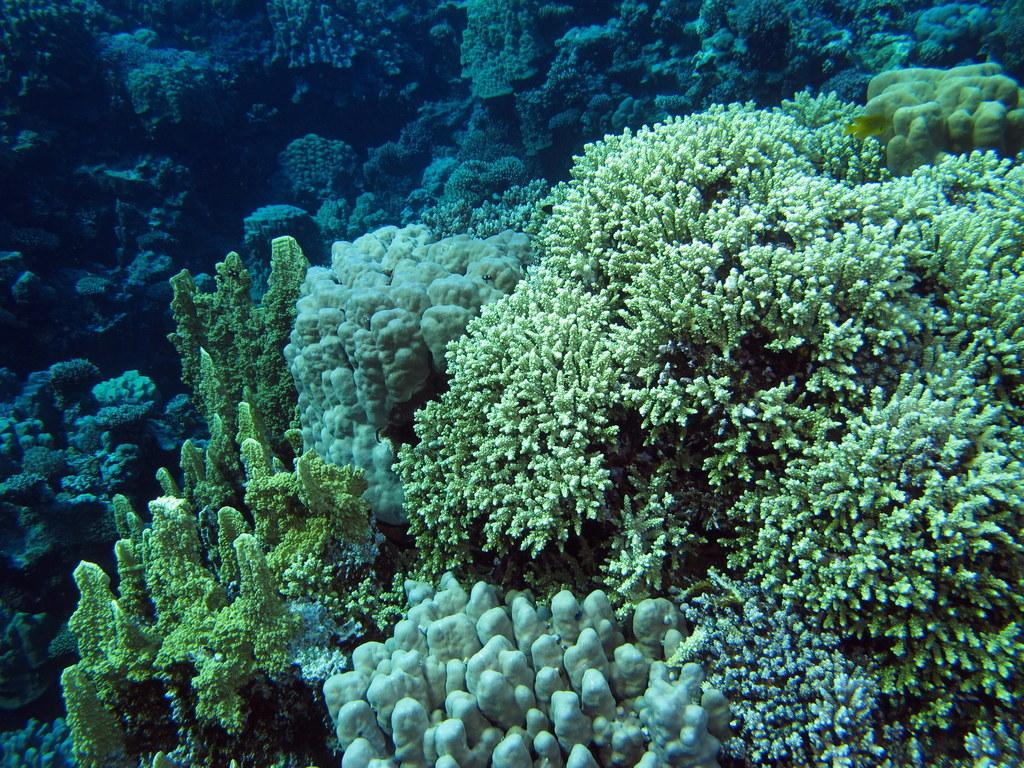What type of plants can be seen in the image? There are underwater plants in the image. How many yaks are swimming with the underwater plants in the image? There are no yaks present in the image; it features underwater plants only. What type of liquid surrounds the underwater plants in the image? The image does not specify the type of liquid surrounding the underwater plants, but it is likely water. 